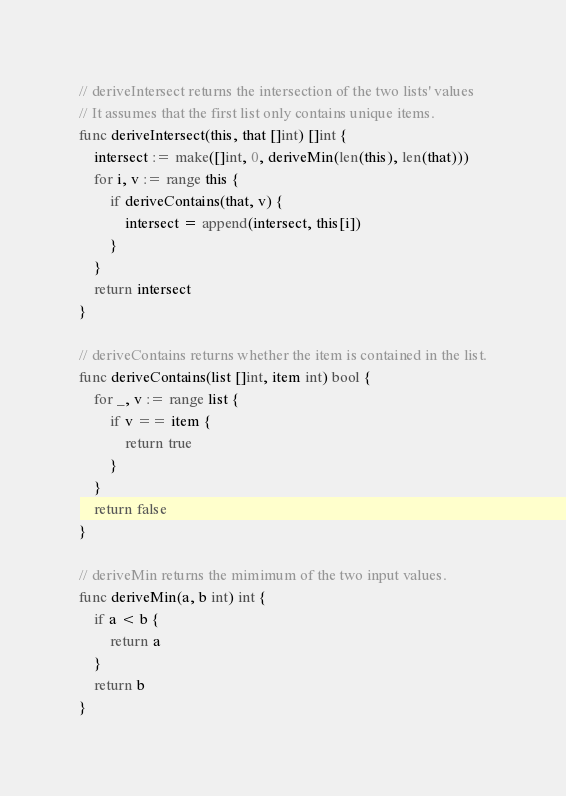Convert code to text. <code><loc_0><loc_0><loc_500><loc_500><_Go_>
// deriveIntersect returns the intersection of the two lists' values
// It assumes that the first list only contains unique items.
func deriveIntersect(this, that []int) []int {
	intersect := make([]int, 0, deriveMin(len(this), len(that)))
	for i, v := range this {
		if deriveContains(that, v) {
			intersect = append(intersect, this[i])
		}
	}
	return intersect
}

// deriveContains returns whether the item is contained in the list.
func deriveContains(list []int, item int) bool {
	for _, v := range list {
		if v == item {
			return true
		}
	}
	return false
}

// deriveMin returns the mimimum of the two input values.
func deriveMin(a, b int) int {
	if a < b {
		return a
	}
	return b
}
</code> 